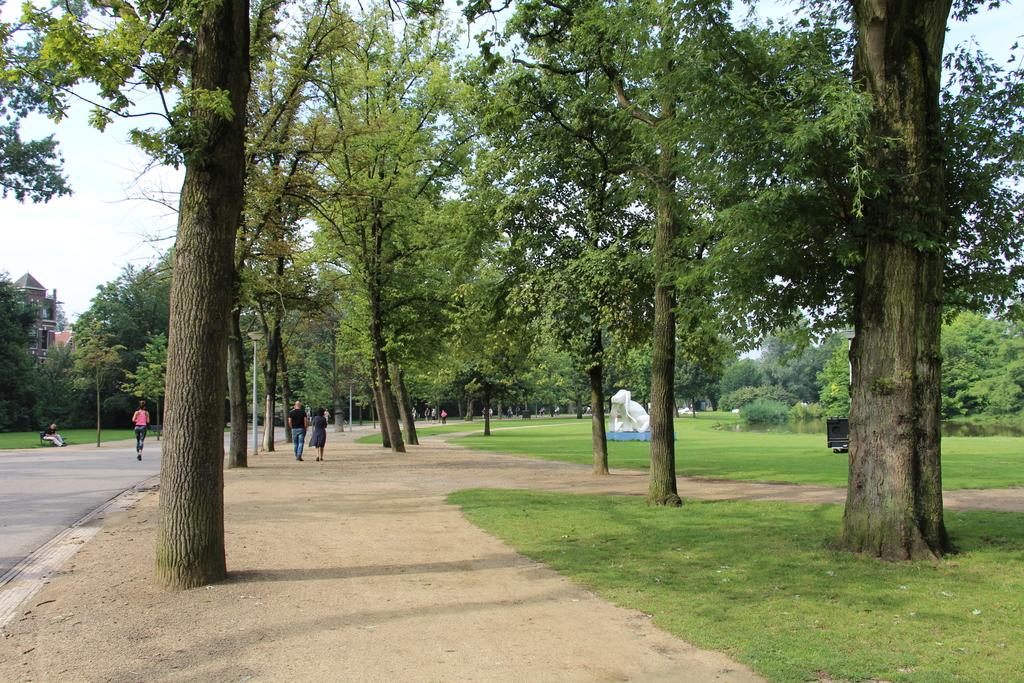What type of natural elements can be seen in the image? There are trees in the image. What is located in the center of the image? There is a walkway in the center of the image. What can be found on the right side of the image? There is a sculpture on the right side of the image. Can you describe the people visible in the image? There are people visible in the image. What is visible in the background of the image? There is a building and the sky in the background of the image. How many cushions are present on the walkway in the image? There are no cushions mentioned or visible in the image. What process is being carried out by the lizards in the image? There are no lizards present in the image. 